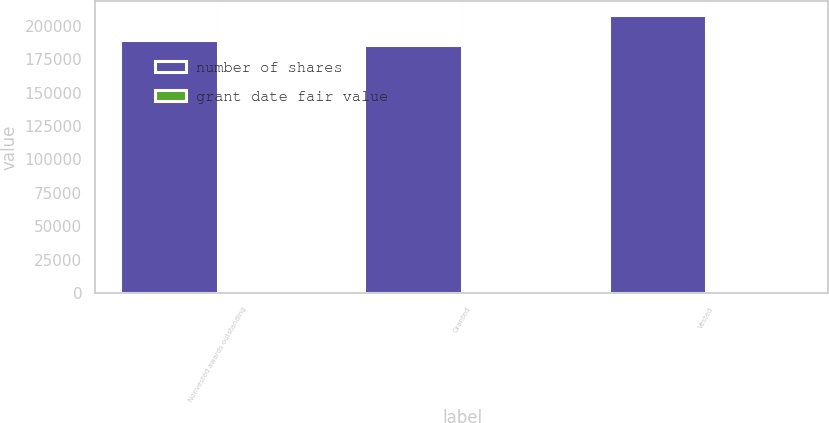Convert chart to OTSL. <chart><loc_0><loc_0><loc_500><loc_500><stacked_bar_chart><ecel><fcel>Nonvested awards outstanding<fcel>Granted<fcel>Vested<nl><fcel>number of shares<fcel>189500<fcel>185700<fcel>207900<nl><fcel>grant date fair value<fcel>63.85<fcel>67.41<fcel>63.27<nl></chart> 